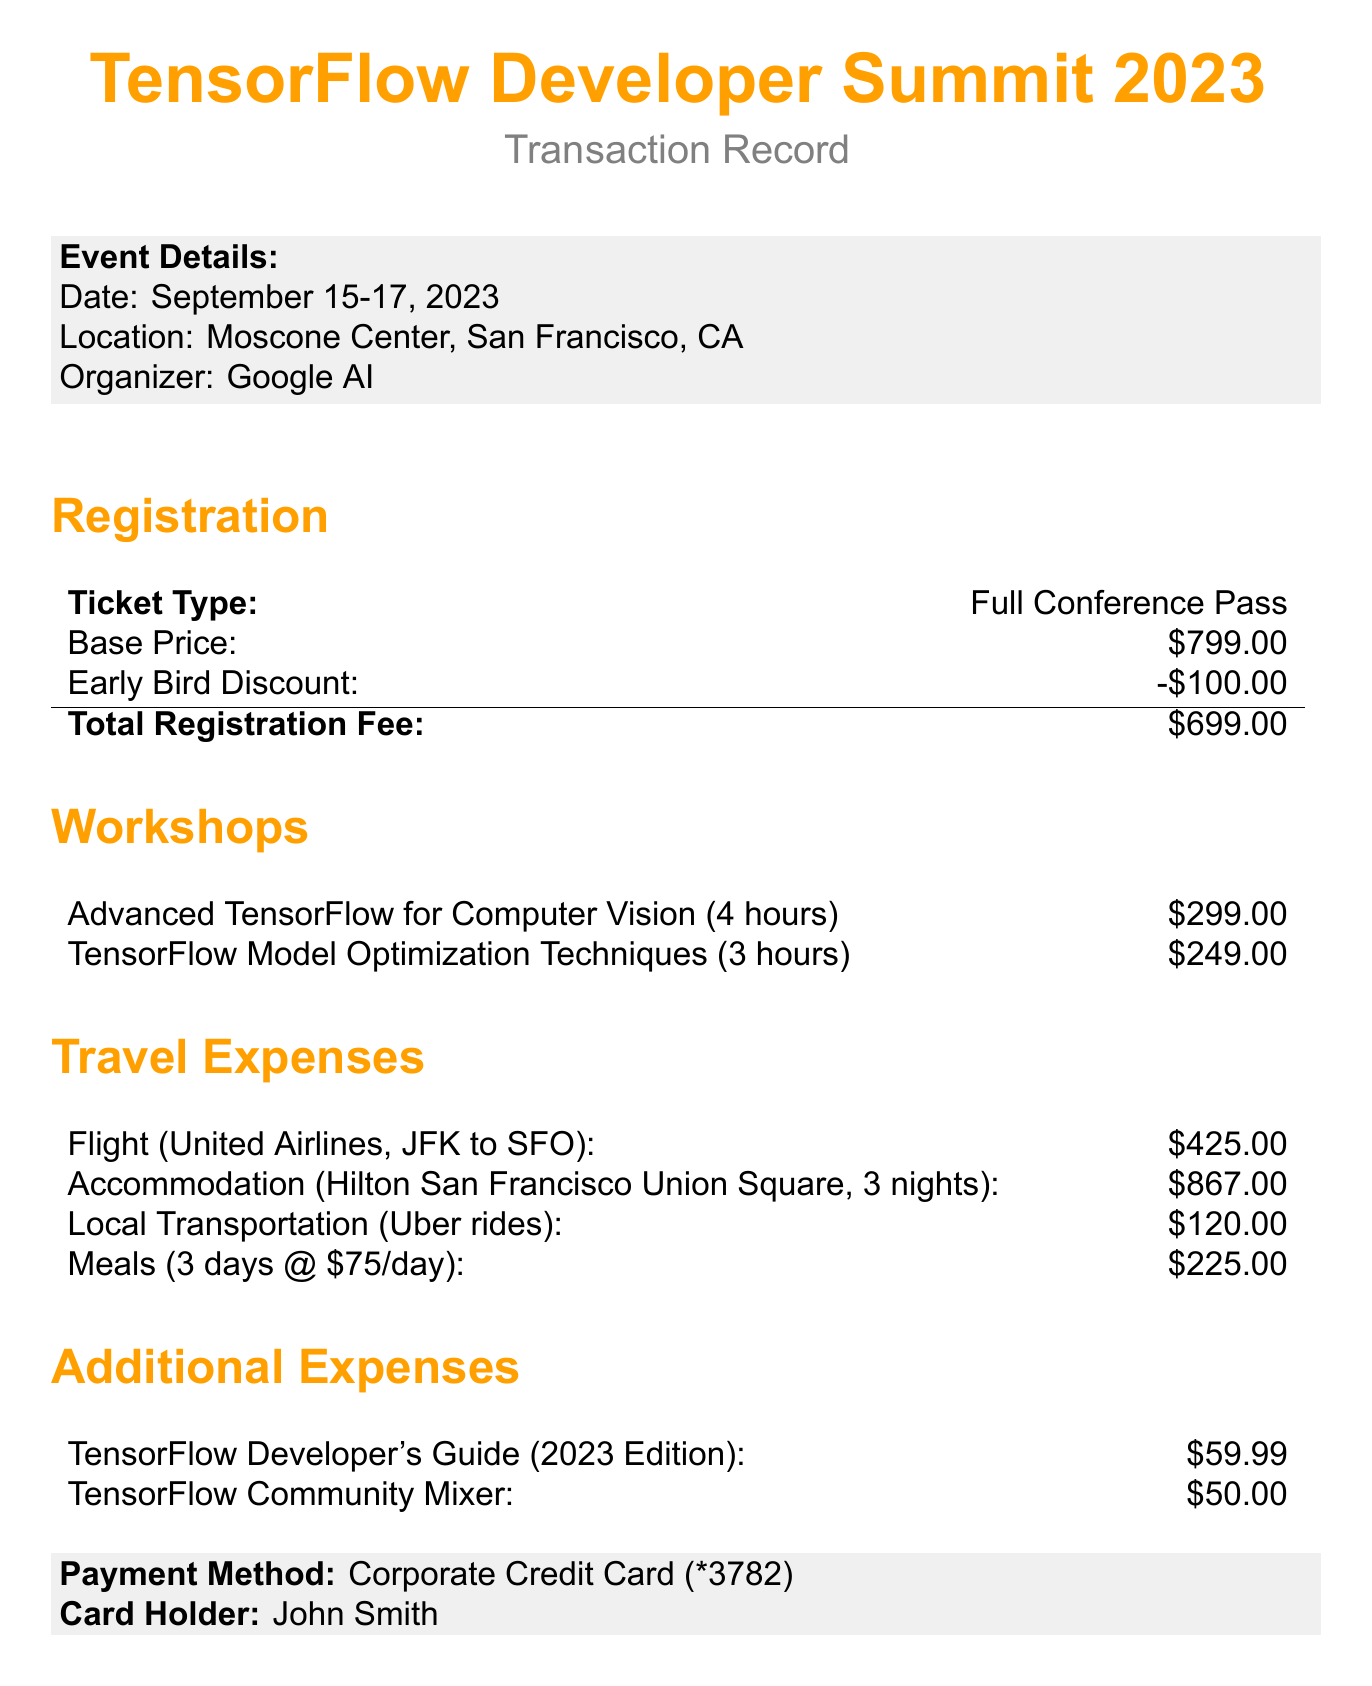What are the dates of the event? The dates of the event are specified in the document as September 15-17, 2023.
Answer: September 15-17, 2023 Who is the instructor for the Advanced TensorFlow workshop? The document lists the instructor for the Advanced TensorFlow workshop as Dr. Andrew Ng.
Answer: Dr. Andrew Ng What is the total registration fee after applying the early bird discount? The total registration fee after the early bird discount is explicitly mentioned in the document as $699.00.
Answer: $699.00 How much is the travel and accommodation expense? The document provides the travel and accommodation expense as a specific total of $1,637.00.
Answer: $1,637.00 What is the total cost of attending the summit? The total cost of attending the summit is noted in the document and amounts to $2,993.99.
Answer: $2,993.99 Which airline is used for the flight? The airline for the flight is specified in the travel expenses section as United Airlines.
Answer: United Airlines What is the cost of the TensorFlow Developer's Guide? The cost of the TensorFlow Developer's Guide is explicitly listed in the additional expenses section as $59.99.
Answer: $59.99 How many nights did the accommodation cover? The accommodation cost is specified for 3 nights in the travel expenses section of the document.
Answer: 3 nights What is the cost per meal per day as mentioned in the document? The document states the meals per diem is $75.00 per day.
Answer: $75.00 